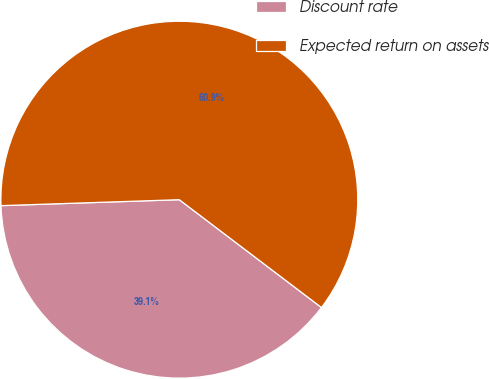<chart> <loc_0><loc_0><loc_500><loc_500><pie_chart><fcel>Discount rate<fcel>Expected return on assets<nl><fcel>39.14%<fcel>60.86%<nl></chart> 